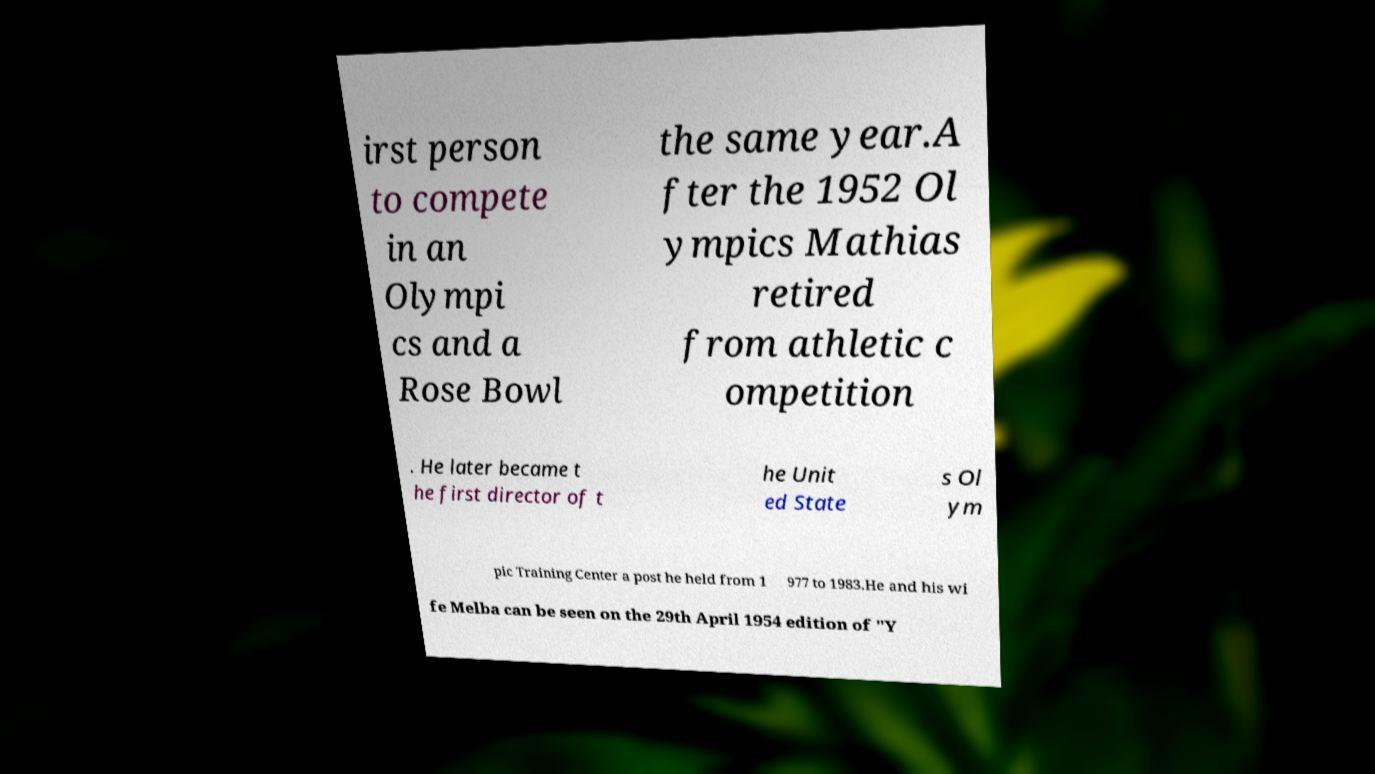Please read and relay the text visible in this image. What does it say? irst person to compete in an Olympi cs and a Rose Bowl the same year.A fter the 1952 Ol ympics Mathias retired from athletic c ompetition . He later became t he first director of t he Unit ed State s Ol ym pic Training Center a post he held from 1 977 to 1983.He and his wi fe Melba can be seen on the 29th April 1954 edition of "Y 